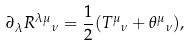<formula> <loc_0><loc_0><loc_500><loc_500>\partial _ { \lambda } { { R } ^ { \lambda \mu } } _ { \nu } = \frac { 1 } { 2 } ( { { T } ^ { \mu } } _ { \nu } + { \theta ^ { \mu } } _ { \nu } ) ,</formula> 